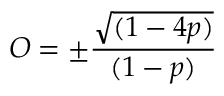<formula> <loc_0><loc_0><loc_500><loc_500>O = \pm \frac { \sqrt { ( 1 - 4 p ) } } { ( 1 - p ) }</formula> 